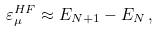<formula> <loc_0><loc_0><loc_500><loc_500>\varepsilon ^ { H F } _ { \mu } \approx E _ { N + 1 } - E _ { N } \, ,</formula> 